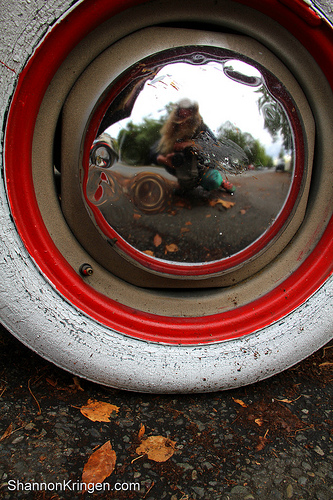<image>
Can you confirm if the tire is on the hub? Yes. Looking at the image, I can see the tire is positioned on top of the hub, with the hub providing support. 